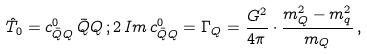Convert formula to latex. <formula><loc_0><loc_0><loc_500><loc_500>\hat { T } _ { 0 } = c _ { { \bar { Q } } Q } ^ { 0 } \, { \bar { Q } } Q \, ; 2 \, I m \, c _ { { \bar { Q } } Q } ^ { 0 } = \Gamma _ { Q } = \frac { G ^ { 2 } } { 4 \pi } \cdot \frac { m _ { Q } ^ { 2 } - m _ { q } ^ { 2 } } { m _ { Q } } \, ,</formula> 